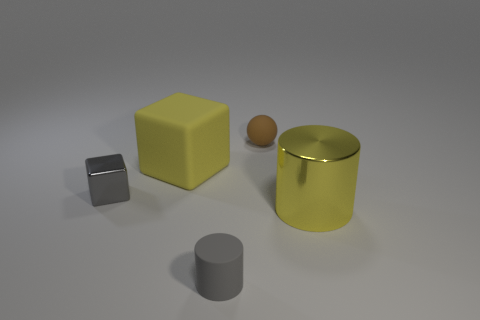Add 4 yellow rubber cylinders. How many objects exist? 9 Subtract all balls. How many objects are left? 4 Subtract 1 cylinders. How many cylinders are left? 1 Subtract all yellow cubes. Subtract all blue cylinders. How many cubes are left? 1 Subtract all cyan spheres. How many red blocks are left? 0 Subtract all tiny matte objects. Subtract all yellow rubber cubes. How many objects are left? 2 Add 5 yellow cylinders. How many yellow cylinders are left? 6 Add 2 small brown spheres. How many small brown spheres exist? 3 Subtract 0 green spheres. How many objects are left? 5 